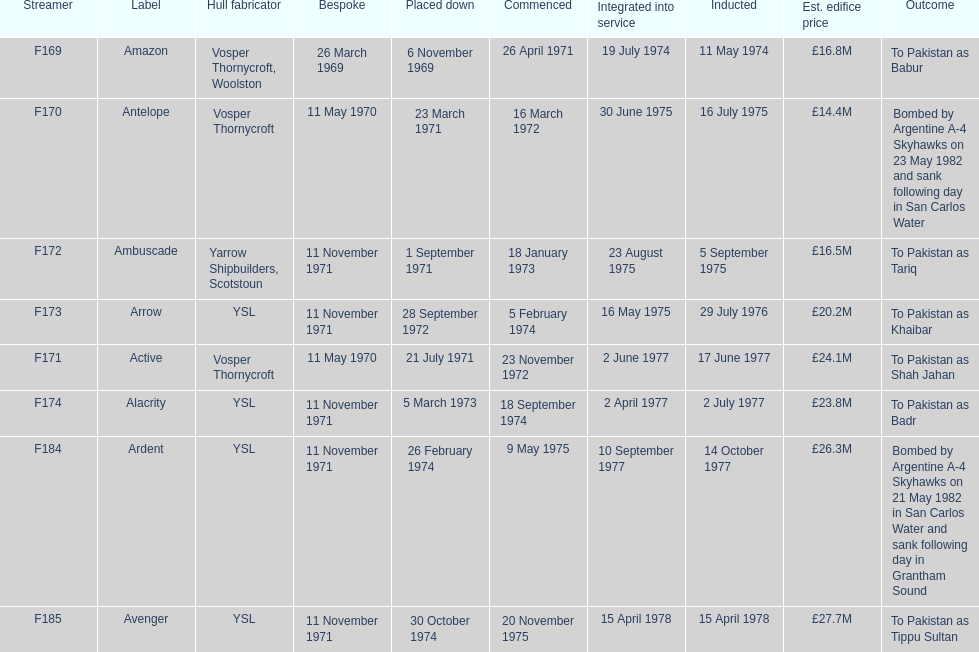What is the last listed pennant? F185. 